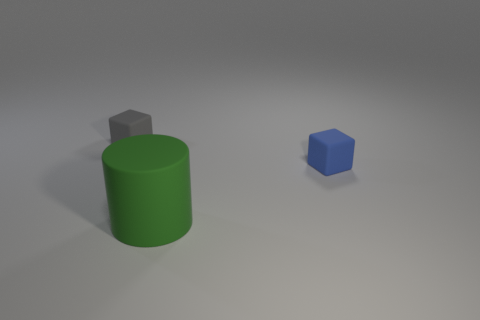There is a blue cube that is the same material as the cylinder; what size is it?
Keep it short and to the point. Small. How many small gray things are the same shape as the green object?
Provide a succinct answer. 0. Do the gray matte object and the tiny rubber thing to the right of the tiny gray rubber cube have the same shape?
Provide a succinct answer. Yes. Are there any tiny green blocks made of the same material as the big green object?
Provide a succinct answer. No. There is a small object right of the tiny block that is on the left side of the green object; what is its material?
Keep it short and to the point. Rubber. There is a rubber cylinder on the right side of the block behind the tiny rubber block that is right of the large green thing; how big is it?
Your response must be concise. Large. What number of other objects are the same shape as the blue object?
Your answer should be very brief. 1. What is the color of the other thing that is the same size as the gray thing?
Provide a succinct answer. Blue. Is there a large matte sphere that has the same color as the cylinder?
Keep it short and to the point. No. There is a cube to the left of the green cylinder; is it the same size as the tiny blue matte block?
Ensure brevity in your answer.  Yes. 